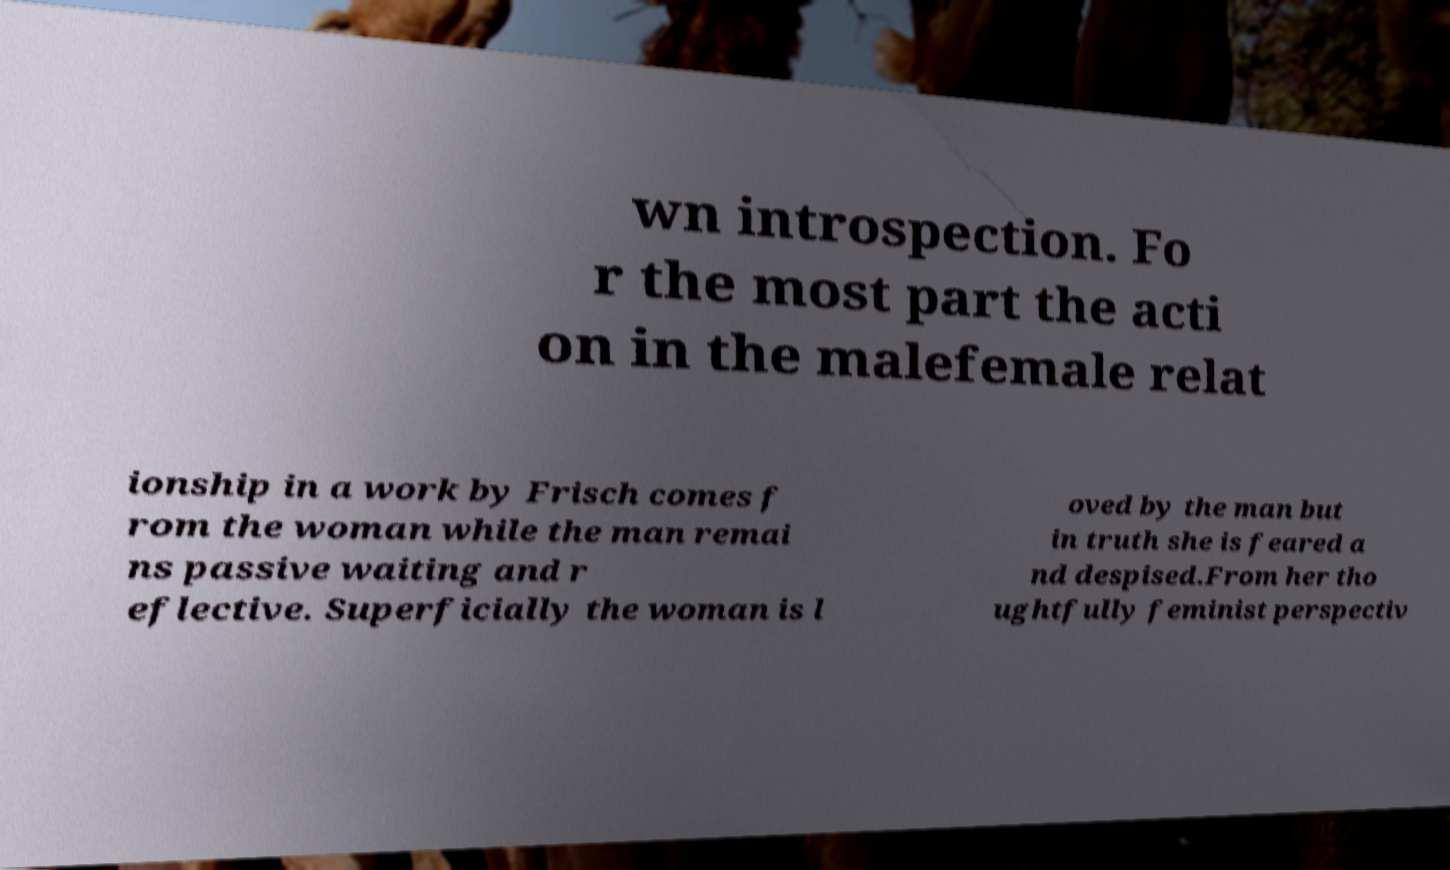Please read and relay the text visible in this image. What does it say? wn introspection. Fo r the most part the acti on in the malefemale relat ionship in a work by Frisch comes f rom the woman while the man remai ns passive waiting and r eflective. Superficially the woman is l oved by the man but in truth she is feared a nd despised.From her tho ughtfully feminist perspectiv 